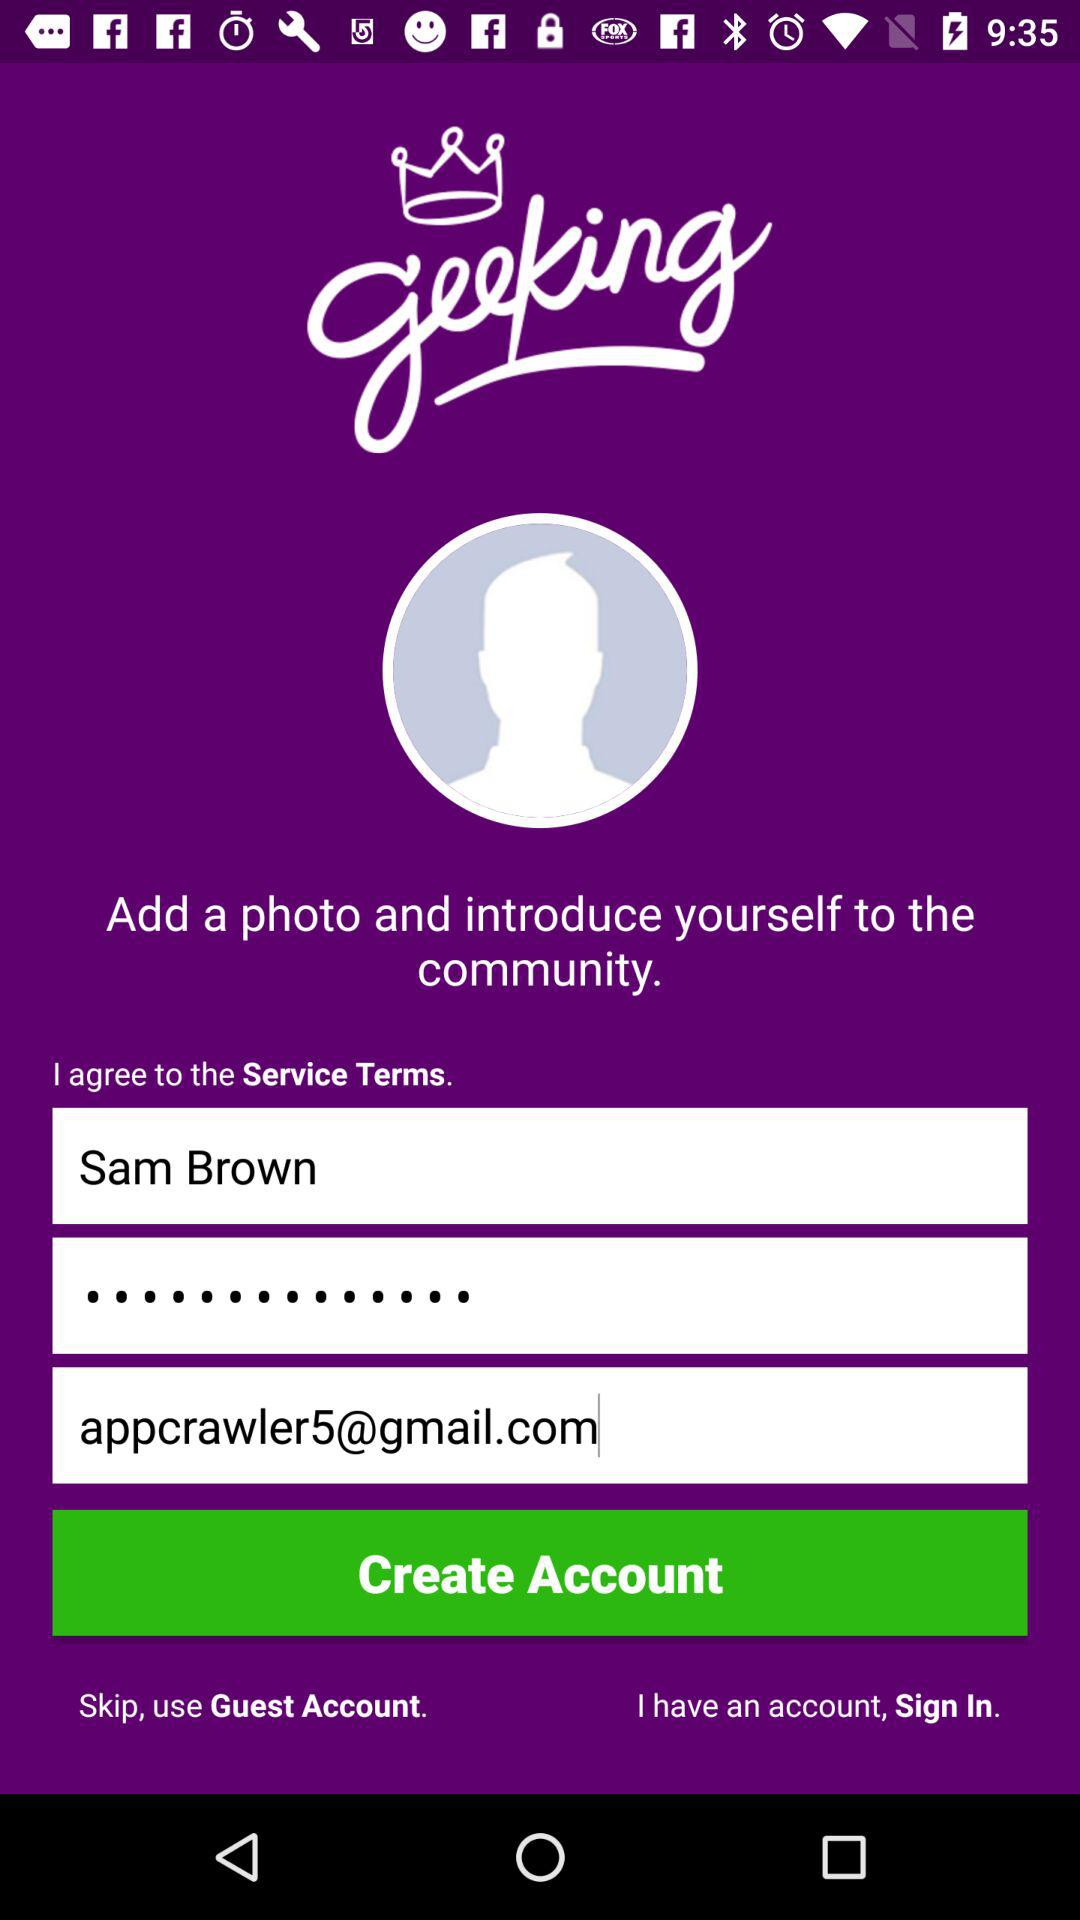What is the email address? The email address is appcrawler5@gmail.com. 